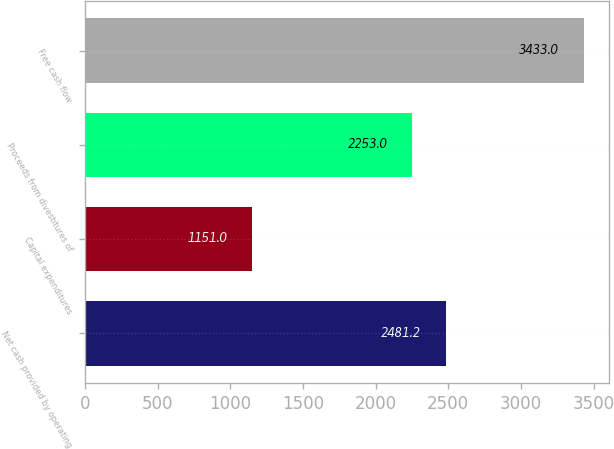<chart> <loc_0><loc_0><loc_500><loc_500><bar_chart><fcel>Net cash provided by operating<fcel>Capital expenditures<fcel>Proceeds from divestitures of<fcel>Free cash flow<nl><fcel>2481.2<fcel>1151<fcel>2253<fcel>3433<nl></chart> 